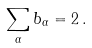<formula> <loc_0><loc_0><loc_500><loc_500>\sum _ { \alpha } b _ { \alpha } = 2 \, .</formula> 